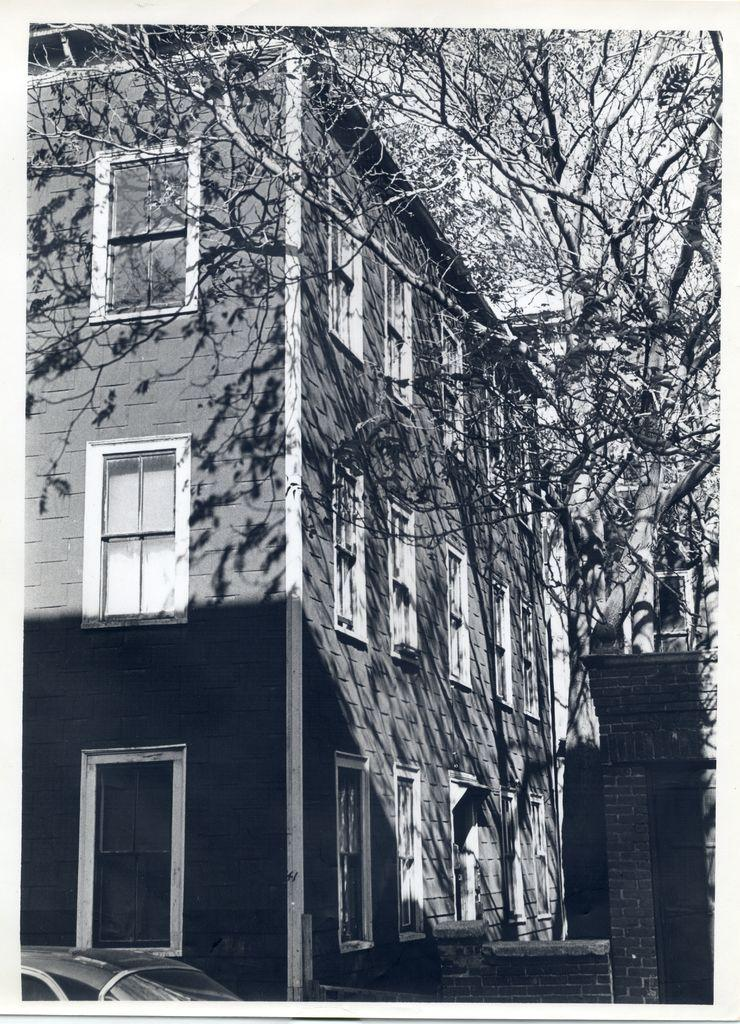What is the color scheme of the image? The image is black and white. What is the main subject in the image? There is a building with windows in the image. Where is the building located in the image? The building is in the middle of the image. What type of vegetation is near the building? There are trees beside the building. What type of vehicle is near the building? There is a car near the building at the bottom of the image. How many sacks of coal are being used to heat the building in the image? There is no indication of sacks of coal or any heating source in the image; it only shows a building, trees, and a car. 